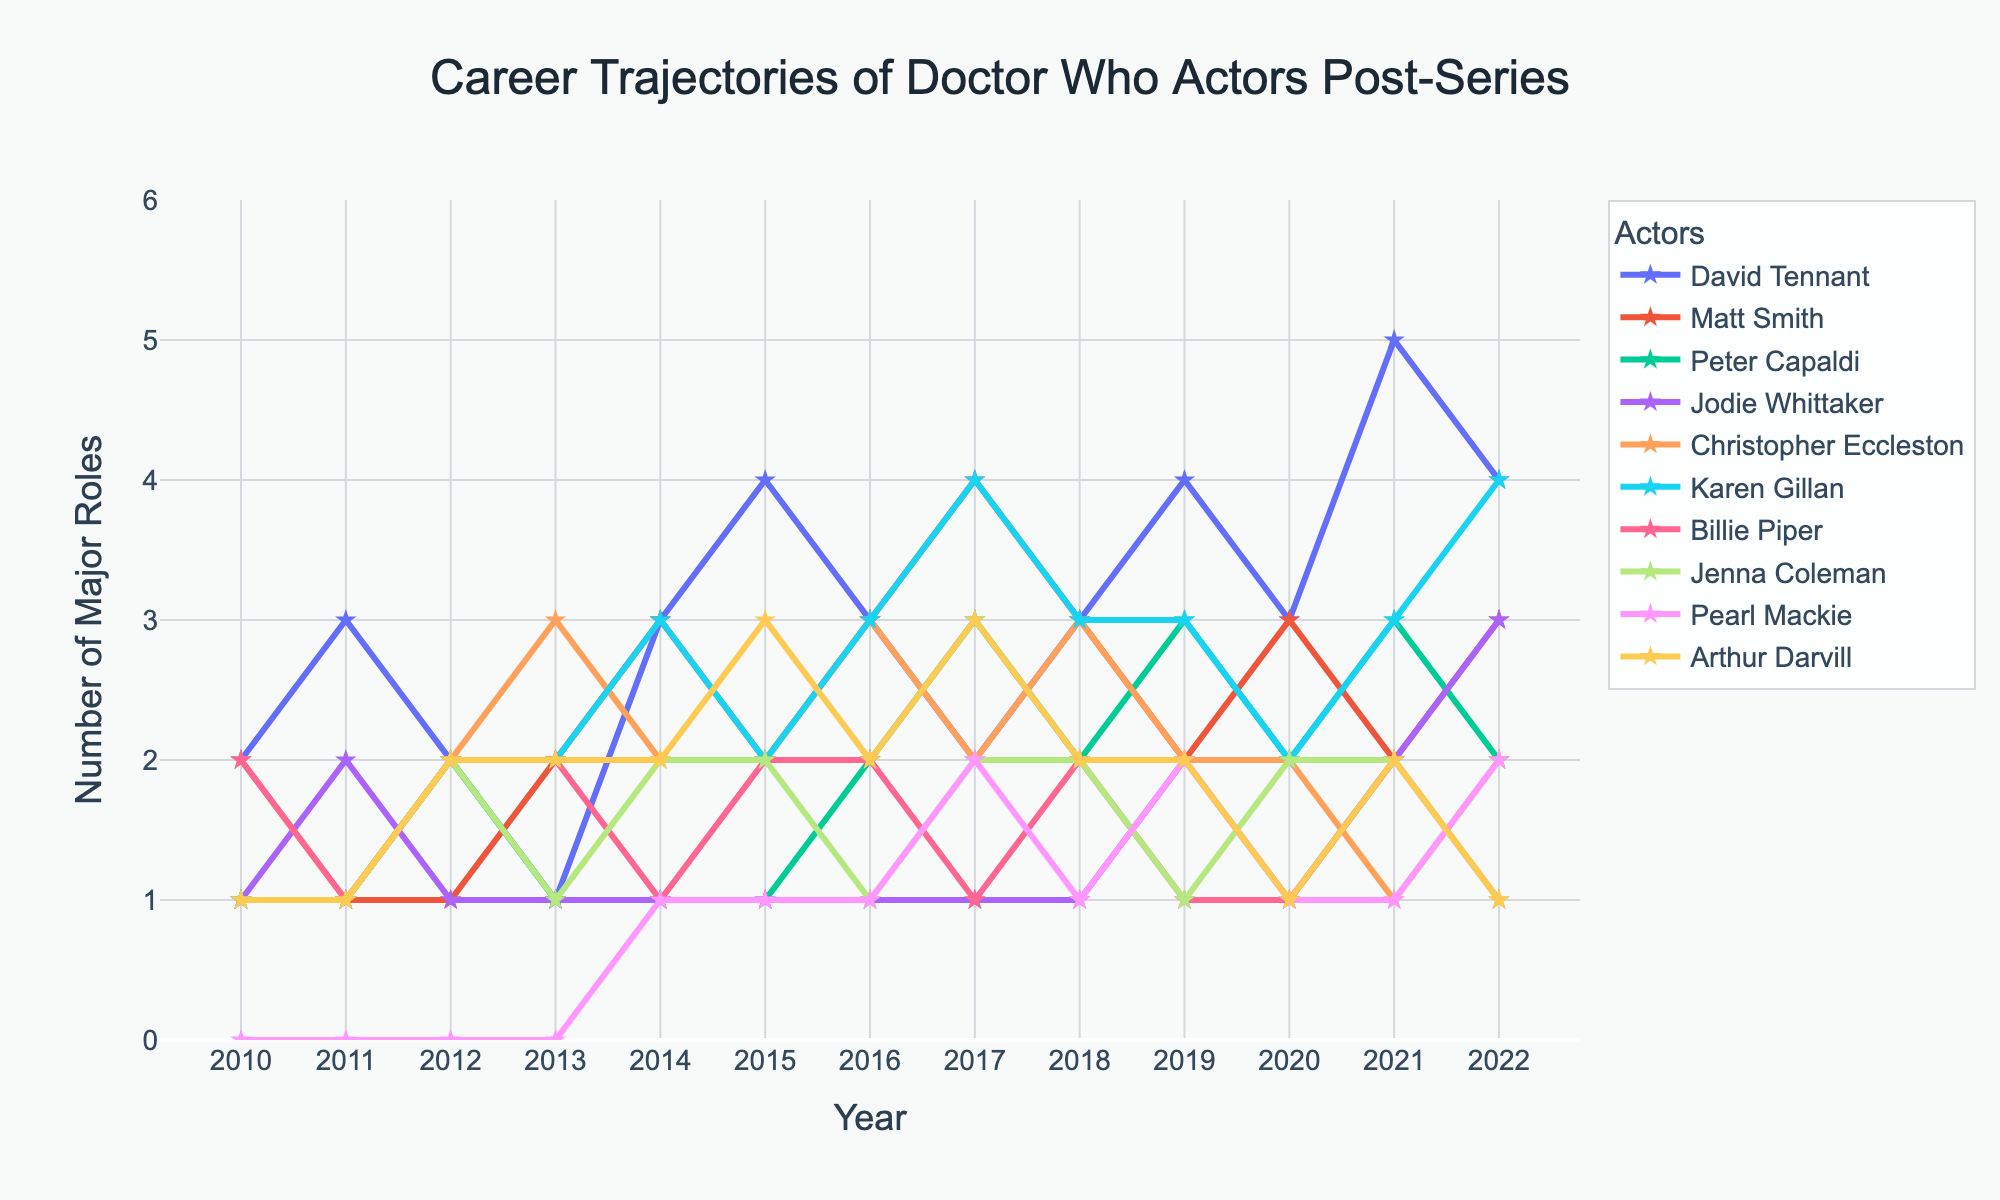Which actor has the most number of major roles in 2022? To determine which actor has the most major roles in 2022, look at the value corresponding to each actor for 2022. David Tennant and Karen Gillan both have 4 major roles, which is the highest.
Answer: David Tennant and Karen Gillan Which years did Matt Smith have the same number of major roles? To find out the years Matt Smith had the same number of major roles, look for repeated values in his line plot. Matt Smith had the same number of roles in 2010, 2011, and 2012 (1 role each), in 2016 and 2018 (both 3 roles), and in 2013 and 2014 (both 2 roles).
Answer: 2010, 2011, 2012, 2013, 2014, 2016, 2018 By how much did David Tennant's number of major roles increase from 2013 to 2015? To find the increase, subtract the number of roles in 2013 from the number in 2015 for David Tennant. In 2013, he had 1 role, and in 2015, he had 4 roles. So, the increase is 4 - 1 = 3.
Answer: 3 roles Which actor shows the most consistent number of major roles over the years? Consistent means the least fluctuation in the number of roles. Jodie Whittaker's line plot shows a near-constant trend, mainly hovering around 1 role each year, barely changing.
Answer: Jodie Whittaker Who had a peak number of major roles in a single year and what year was it? Find the highest point on the graph for each actor and identify the highest single-year value overall. David Tennant's peak was 5 roles in 2021. This is the highest number of major roles any actor had in a single year.
Answer: David Tennant in 2021 Between 2015 and 2017, which actor’s career trajectory showed the greatest upward trend? To determine the greatest upward trend between 2015 and 2017, calculate the difference in roles between these years for each actor. Karen Gillan increased from 2 roles in 2015 to 4 roles in 2017, a difference of 4 - 2 = 2, which is the largest increase.
Answer: Karen Gillan Compare David Tennant and Peter Capaldi's total number of roles from 2010 to 2022. Who had more and by how much? Add up the number of roles for each year from 2010 to 2022 for both actors. David Tennant has a total of 39 roles, while Peter Capaldi has 24. The difference is 39 - 24 = 15.
Answer: David Tennant by 15 roles Which actor had no major roles for the least amount of time? Identify the actors and the corresponding number of years where their roles were zero. Pearl Mackie is the only actor that had zero roles, and she had only zero roles in the years before 2014 (4 years).
Answer: Pearl Mackie 